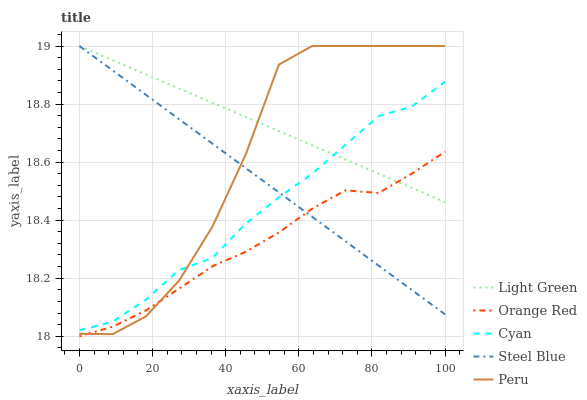Does Orange Red have the minimum area under the curve?
Answer yes or no. Yes. Does Light Green have the maximum area under the curve?
Answer yes or no. Yes. Does Cyan have the minimum area under the curve?
Answer yes or no. No. Does Cyan have the maximum area under the curve?
Answer yes or no. No. Is Light Green the smoothest?
Answer yes or no. Yes. Is Peru the roughest?
Answer yes or no. Yes. Is Cyan the smoothest?
Answer yes or no. No. Is Cyan the roughest?
Answer yes or no. No. Does Orange Red have the lowest value?
Answer yes or no. Yes. Does Cyan have the lowest value?
Answer yes or no. No. Does Steel Blue have the highest value?
Answer yes or no. Yes. Does Cyan have the highest value?
Answer yes or no. No. Is Orange Red less than Cyan?
Answer yes or no. Yes. Is Cyan greater than Orange Red?
Answer yes or no. Yes. Does Peru intersect Cyan?
Answer yes or no. Yes. Is Peru less than Cyan?
Answer yes or no. No. Is Peru greater than Cyan?
Answer yes or no. No. Does Orange Red intersect Cyan?
Answer yes or no. No. 